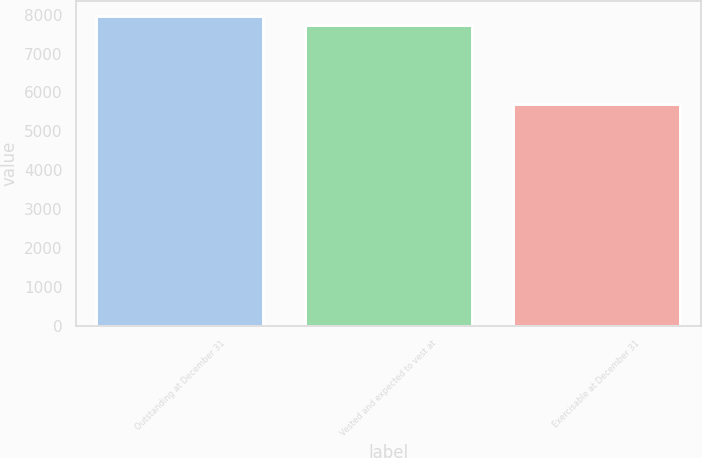<chart> <loc_0><loc_0><loc_500><loc_500><bar_chart><fcel>Outstanding at December 31<fcel>Vested and expected to vest at<fcel>Exercisable at December 31<nl><fcel>7955.3<fcel>7742<fcel>5695<nl></chart> 